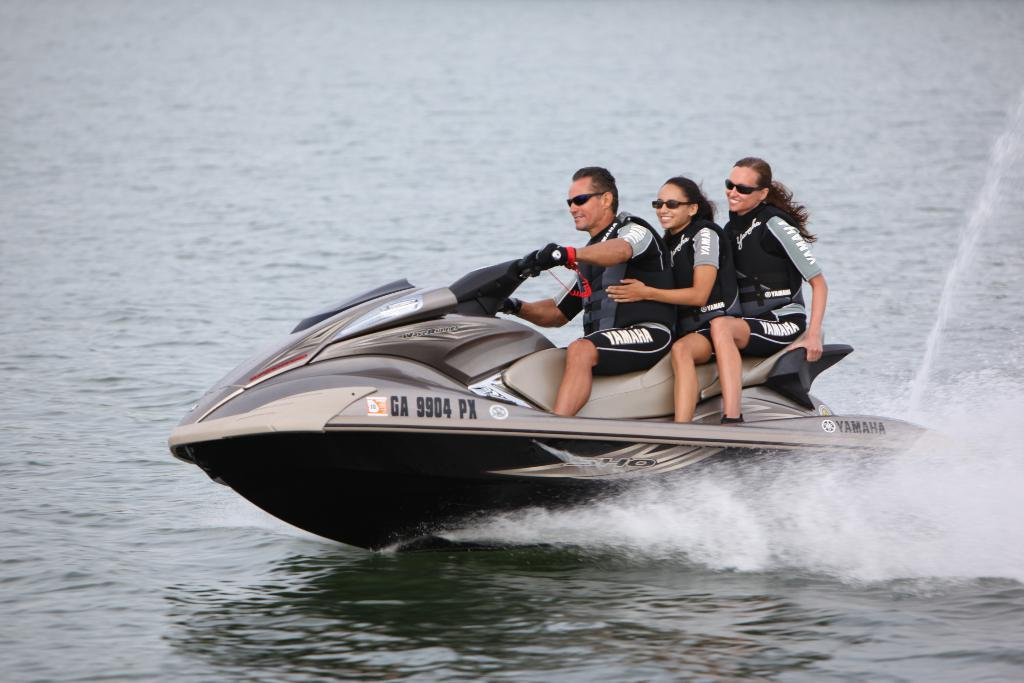How many people are in the image? There are three persons in the image. What are the persons doing in the image? The persons are riding a motor boat. Where is the motor boat located in the image? The motor boat is in the middle of the image. What can be seen in the background of the image? There is a sea in the background of the image. What sense is being stimulated by the boat in the image? The image does not provide information about any senses being stimulated by the boat. --- Facts: 1. There is a person holding a camera in the image. 2. The person is standing on a bridge. 3. There is a river below the bridge. 4. The sky is visible in the image. Absurd Topics: dance, flowers, fence Conversation: What is the person in the image holding? The person in the image is holding a camera. Where is the person standing in the image? The person is standing on a bridge. What can be seen below the bridge in the image? There is a river below the bridge. What is visible in the sky in the image? The sky is visible in the image. Reasoning: Let's think step by step in order to produce the conversation. We start by identifying the main subject in the image, which is the person holding a camera. Then, we describe where the person is standing, which is on a bridge. Next, we mention what can be seen below the bridge, which is a river. Finally, we acknowledge the presence of the sky in the image. Each question is designed to elicit a specific detail about the image that is known from the provided facts. Absurd Question/Answer: What type of flowers can be seen growing on the fence in the image? There is no fence or flowers present in the image. 